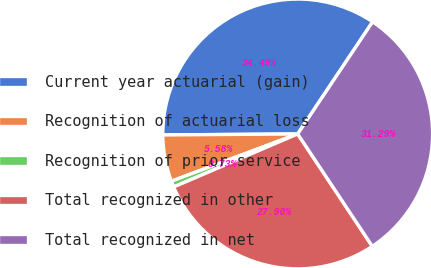Convert chart to OTSL. <chart><loc_0><loc_0><loc_500><loc_500><pie_chart><fcel>Current year actuarial (gain)<fcel>Recognition of actuarial loss<fcel>Recognition of prior service<fcel>Total recognized in other<fcel>Total recognized in net<nl><fcel>34.49%<fcel>5.58%<fcel>0.73%<fcel>27.9%<fcel>31.29%<nl></chart> 